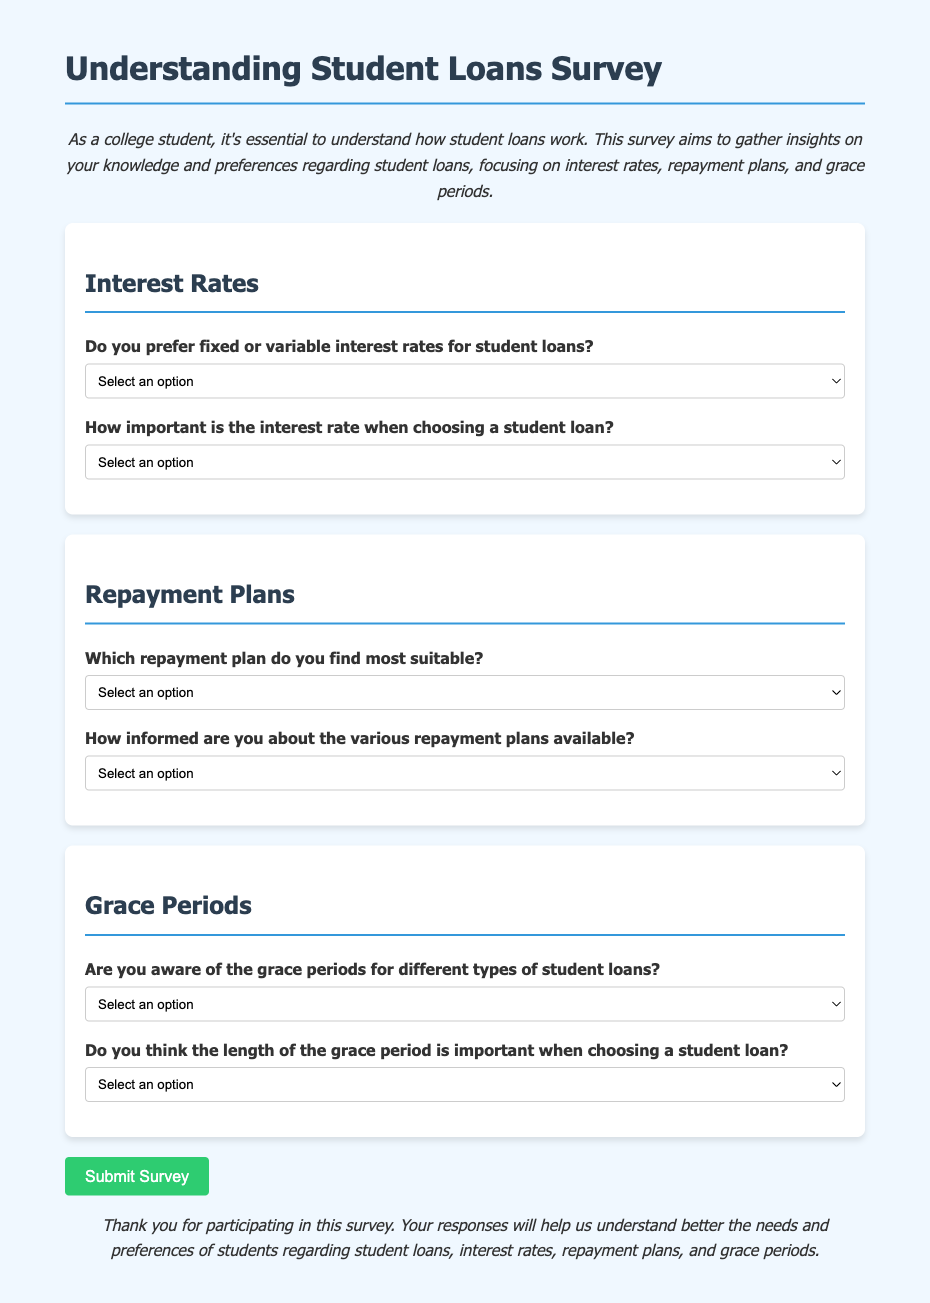What is the title of the survey? The title of the survey is prominently displayed at the top of the document, indicating the focus on student loans.
Answer: Understanding Student Loans Survey What is the color of the background used in the survey? The background color is specified in the CSS styling in the document, creating a light appearance.
Answer: Light blue How many sections are there in the survey? The survey is divided into three main sections focusing on different aspects of student loans.
Answer: Three What type of repayment plan options are provided in the survey? The survey includes multiple-choice options to assess preferences regarding repayment plans.
Answer: Standard, Graduated, Income-Driven What is the importance level of the interest rate when choosing a student loan according to the survey? The survey queries participants on their perception of the interest rate's importance as a factor in decision-making.
Answer: Very Important, Somewhat Important, Not Important How will participants submit their responses? The survey includes a button meant for submitting completed answers, signifying the end of participation.
Answer: Submit Survey Are participants asked about their awareness of grace periods? One of the questions in the survey specifically addresses participants' knowledge about grace periods related to loans.
Answer: Yes/No/Not Sure What is the style used for headers in the survey document? The document's CSS defines how headers are styled to enhance readability and visual hierarchy.
Answer: Bold and colored How is the survey form's conclusion presented? The conclusion section offers gratitude towards the participants for their contribution, enhancing the participant's experience.
Answer: Thank you for participating in this survey 